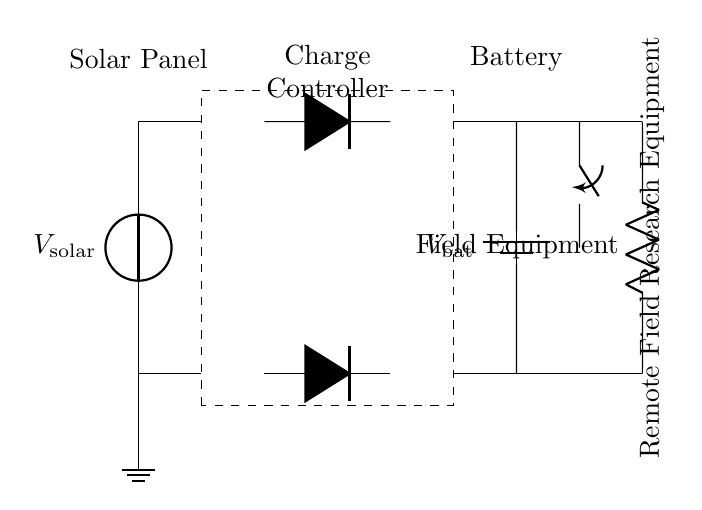What type of circuit is this? This circuit is a solar-powered charging circuit, as indicated by the presence of a solar panel and components needed to charge a battery for field equipment use.
Answer: Solar-powered charging circuit What component regulates the energy flow from the solar panel? The charge controller is responsible for regulating the energy flow from the solar panel to the battery, preventing overcharging. This is highlighted by the dashed rectangle labeled as "Charge Controller."
Answer: Charge Controller How many diodes are used in the circuit? The diagram shows two diodes, one connected between the solar panel and charge controller and another between the charge controller and battery. They are denoted by the symbol "D."
Answer: Two What is the function of the switch in this circuit? The switch is used to connect or disconnect the load (field equipment) from the battery, allowing control over the power supplied to the equipment. This can be inferred by its position between the battery and the field equipment load.
Answer: To control connection to field equipment What is the purpose of the battery in this circuit? The battery stores energy collected from the solar panel via the charge controller, providing a stable power supply to the field equipment when sunlight is not available. Its role is indicated as a power reservoir for the system.
Answer: Energy storage What connects the solar panel to the charge controller? The connection is made through a wire, indicated by the line connecting the top terminals of the solar panel and charge controller. This allows for current flow from the solar panel to the charging circuit.
Answer: A wire What is the output voltage of the battery expected to be? The output voltage of the battery, labeled as "V_bat," is typically standard for charging applications. Given no specific value in the diagram, one might assume it’s a common voltage like 12 volts unless otherwise specified.
Answer: V_bat (typically 12 volts) 